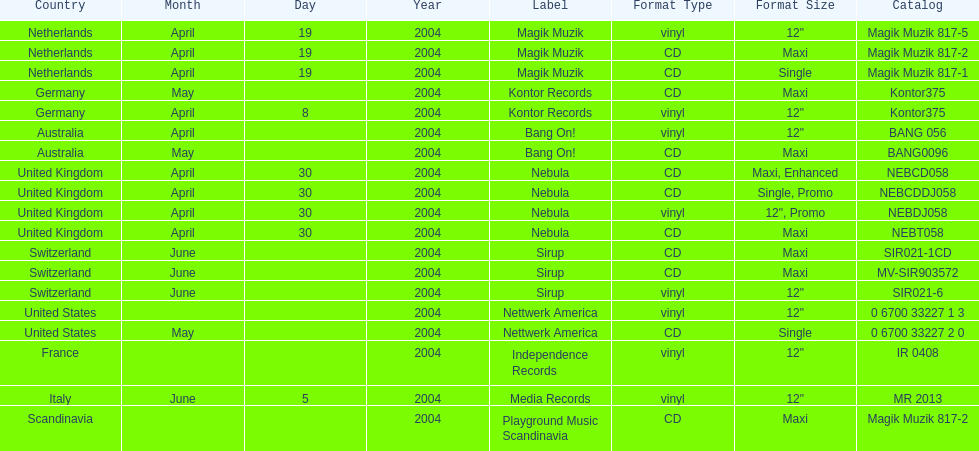What format did france use? Vinyl, 12". 